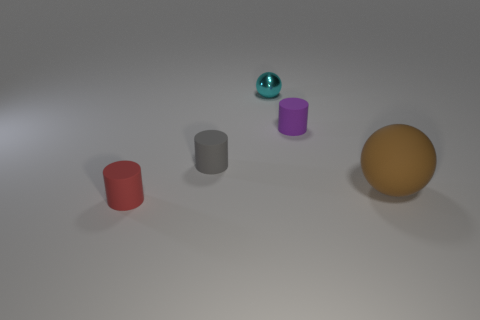The metallic sphere that is the same size as the gray object is what color?
Offer a very short reply. Cyan. What number of matte cylinders are there?
Your answer should be very brief. 3. Do the tiny cylinder on the right side of the tiny ball and the tiny cyan ball have the same material?
Your answer should be compact. No. The small thing that is both behind the gray matte cylinder and in front of the tiny metallic ball is made of what material?
Offer a very short reply. Rubber. What material is the ball that is right of the small matte thing that is on the right side of the shiny ball?
Provide a short and direct response. Rubber. What is the size of the ball in front of the ball that is on the left side of the cylinder to the right of the tiny shiny ball?
Your response must be concise. Large. What number of other large balls are the same material as the big sphere?
Your response must be concise. 0. The thing that is in front of the ball on the right side of the tiny purple cylinder is what color?
Your answer should be compact. Red. How many objects are yellow matte things or spheres that are in front of the small gray rubber cylinder?
Provide a succinct answer. 1. What number of brown objects are either large matte things or tiny metal cylinders?
Your answer should be very brief. 1. 